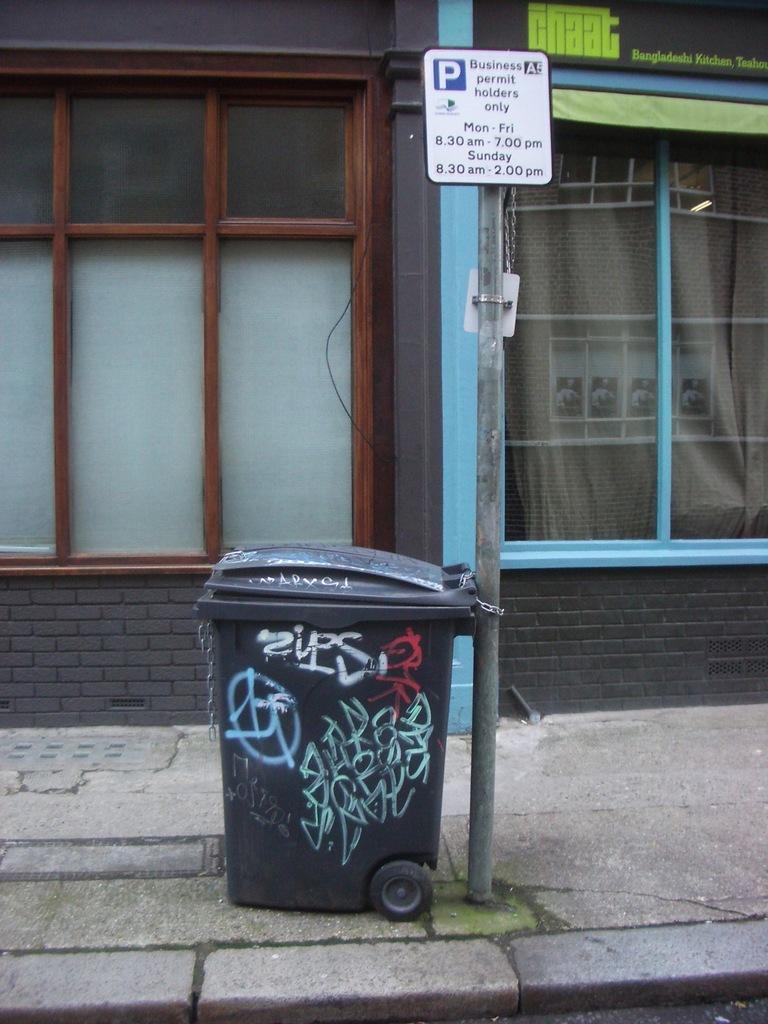Please provide a concise description of this image. In this image we can able to see a dustbin tied to a sign board, and there are windows beside to it. 